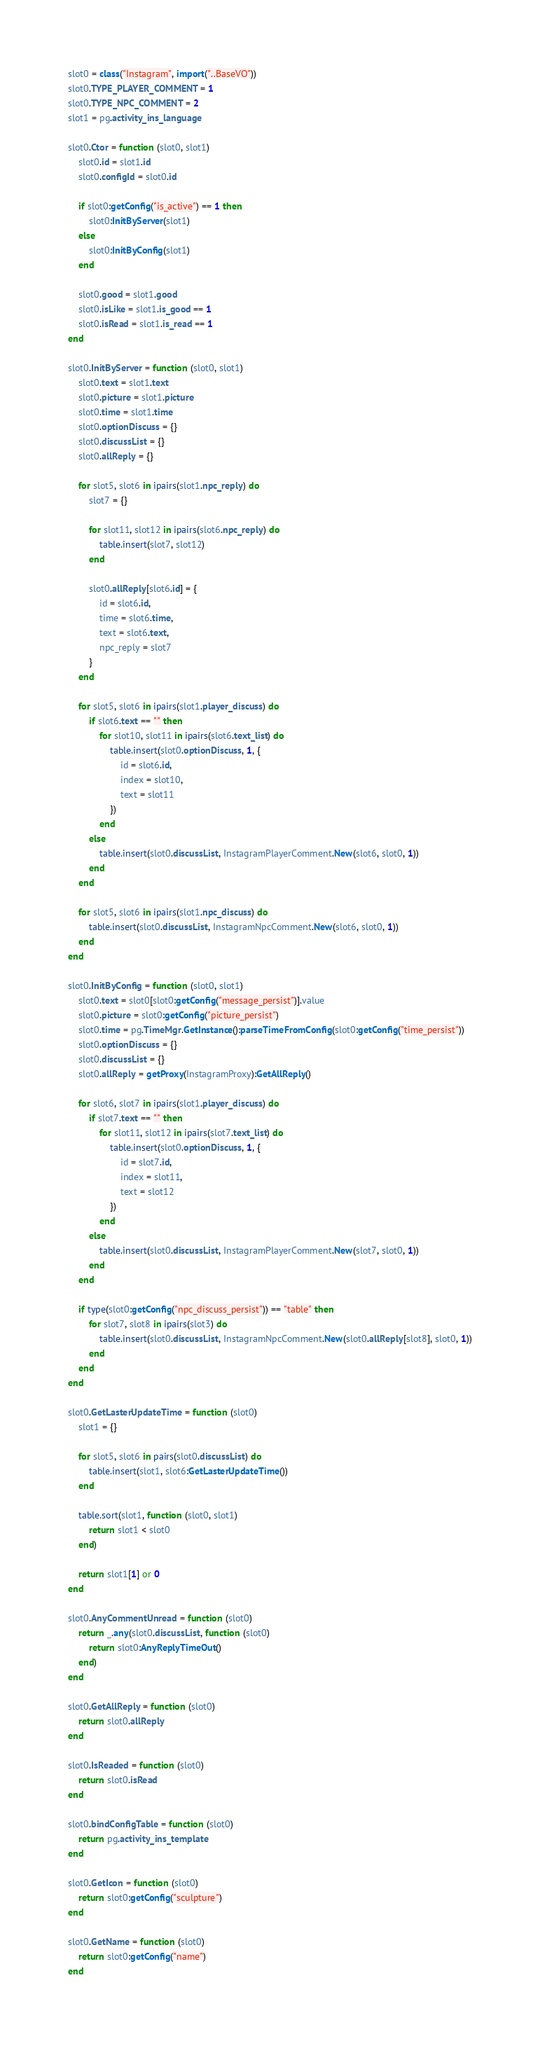<code> <loc_0><loc_0><loc_500><loc_500><_Lua_>slot0 = class("Instagram", import("..BaseVO"))
slot0.TYPE_PLAYER_COMMENT = 1
slot0.TYPE_NPC_COMMENT = 2
slot1 = pg.activity_ins_language

slot0.Ctor = function (slot0, slot1)
	slot0.id = slot1.id
	slot0.configId = slot0.id

	if slot0:getConfig("is_active") == 1 then
		slot0:InitByServer(slot1)
	else
		slot0:InitByConfig(slot1)
	end

	slot0.good = slot1.good
	slot0.isLike = slot1.is_good == 1
	slot0.isRead = slot1.is_read == 1
end

slot0.InitByServer = function (slot0, slot1)
	slot0.text = slot1.text
	slot0.picture = slot1.picture
	slot0.time = slot1.time
	slot0.optionDiscuss = {}
	slot0.discussList = {}
	slot0.allReply = {}

	for slot5, slot6 in ipairs(slot1.npc_reply) do
		slot7 = {}

		for slot11, slot12 in ipairs(slot6.npc_reply) do
			table.insert(slot7, slot12)
		end

		slot0.allReply[slot6.id] = {
			id = slot6.id,
			time = slot6.time,
			text = slot6.text,
			npc_reply = slot7
		}
	end

	for slot5, slot6 in ipairs(slot1.player_discuss) do
		if slot6.text == "" then
			for slot10, slot11 in ipairs(slot6.text_list) do
				table.insert(slot0.optionDiscuss, 1, {
					id = slot6.id,
					index = slot10,
					text = slot11
				})
			end
		else
			table.insert(slot0.discussList, InstagramPlayerComment.New(slot6, slot0, 1))
		end
	end

	for slot5, slot6 in ipairs(slot1.npc_discuss) do
		table.insert(slot0.discussList, InstagramNpcComment.New(slot6, slot0, 1))
	end
end

slot0.InitByConfig = function (slot0, slot1)
	slot0.text = slot0[slot0:getConfig("message_persist")].value
	slot0.picture = slot0:getConfig("picture_persist")
	slot0.time = pg.TimeMgr.GetInstance():parseTimeFromConfig(slot0:getConfig("time_persist"))
	slot0.optionDiscuss = {}
	slot0.discussList = {}
	slot0.allReply = getProxy(InstagramProxy):GetAllReply()

	for slot6, slot7 in ipairs(slot1.player_discuss) do
		if slot7.text == "" then
			for slot11, slot12 in ipairs(slot7.text_list) do
				table.insert(slot0.optionDiscuss, 1, {
					id = slot7.id,
					index = slot11,
					text = slot12
				})
			end
		else
			table.insert(slot0.discussList, InstagramPlayerComment.New(slot7, slot0, 1))
		end
	end

	if type(slot0:getConfig("npc_discuss_persist")) == "table" then
		for slot7, slot8 in ipairs(slot3) do
			table.insert(slot0.discussList, InstagramNpcComment.New(slot0.allReply[slot8], slot0, 1))
		end
	end
end

slot0.GetLasterUpdateTime = function (slot0)
	slot1 = {}

	for slot5, slot6 in pairs(slot0.discussList) do
		table.insert(slot1, slot6:GetLasterUpdateTime())
	end

	table.sort(slot1, function (slot0, slot1)
		return slot1 < slot0
	end)

	return slot1[1] or 0
end

slot0.AnyCommentUnread = function (slot0)
	return _.any(slot0.discussList, function (slot0)
		return slot0:AnyReplyTimeOut()
	end)
end

slot0.GetAllReply = function (slot0)
	return slot0.allReply
end

slot0.IsReaded = function (slot0)
	return slot0.isRead
end

slot0.bindConfigTable = function (slot0)
	return pg.activity_ins_template
end

slot0.GetIcon = function (slot0)
	return slot0:getConfig("sculpture")
end

slot0.GetName = function (slot0)
	return slot0:getConfig("name")
end
</code> 